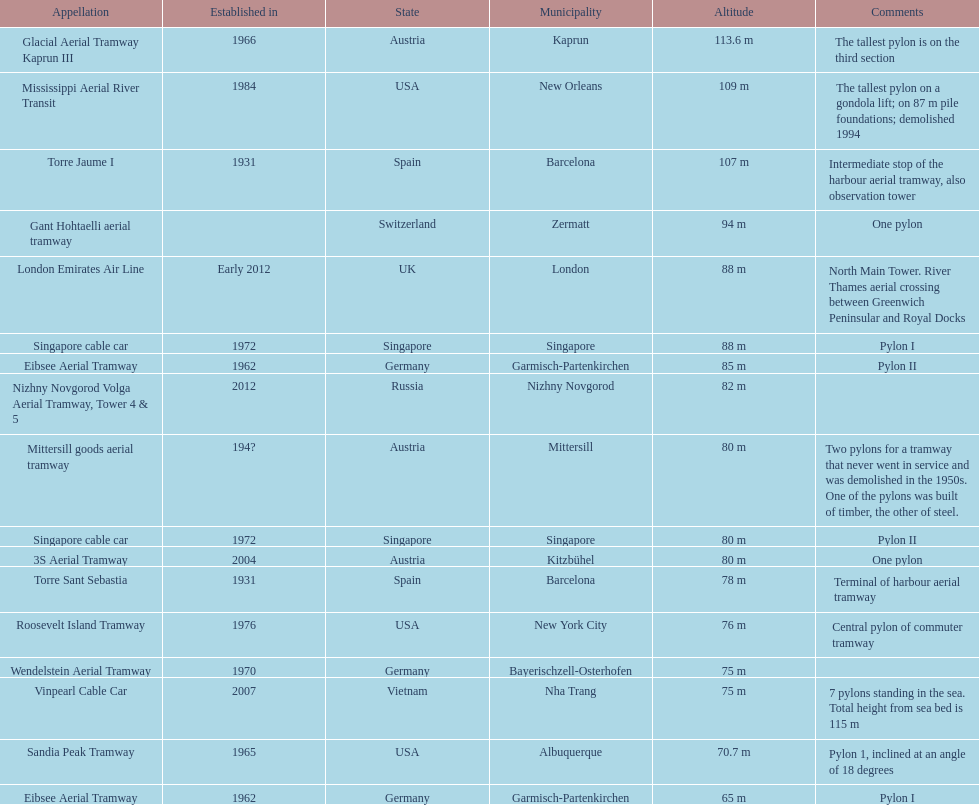How many metres is the mississippi aerial river transit from bottom to top? 109 m. 